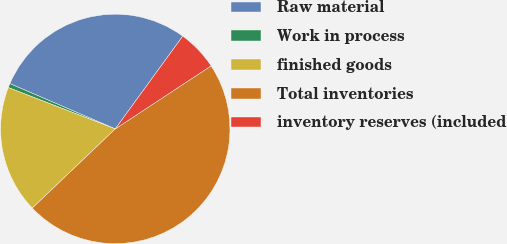Convert chart to OTSL. <chart><loc_0><loc_0><loc_500><loc_500><pie_chart><fcel>Raw material<fcel>Work in process<fcel>finished goods<fcel>Total inventories<fcel>inventory reserves (included<nl><fcel>28.55%<fcel>0.59%<fcel>18.0%<fcel>47.14%<fcel>5.73%<nl></chart> 